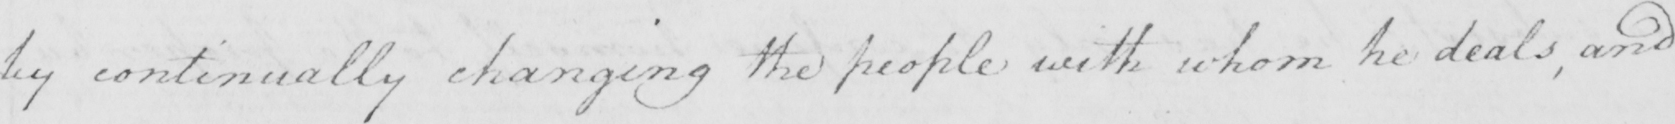Please transcribe the handwritten text in this image. by continually changing the people with whom he deals , and 